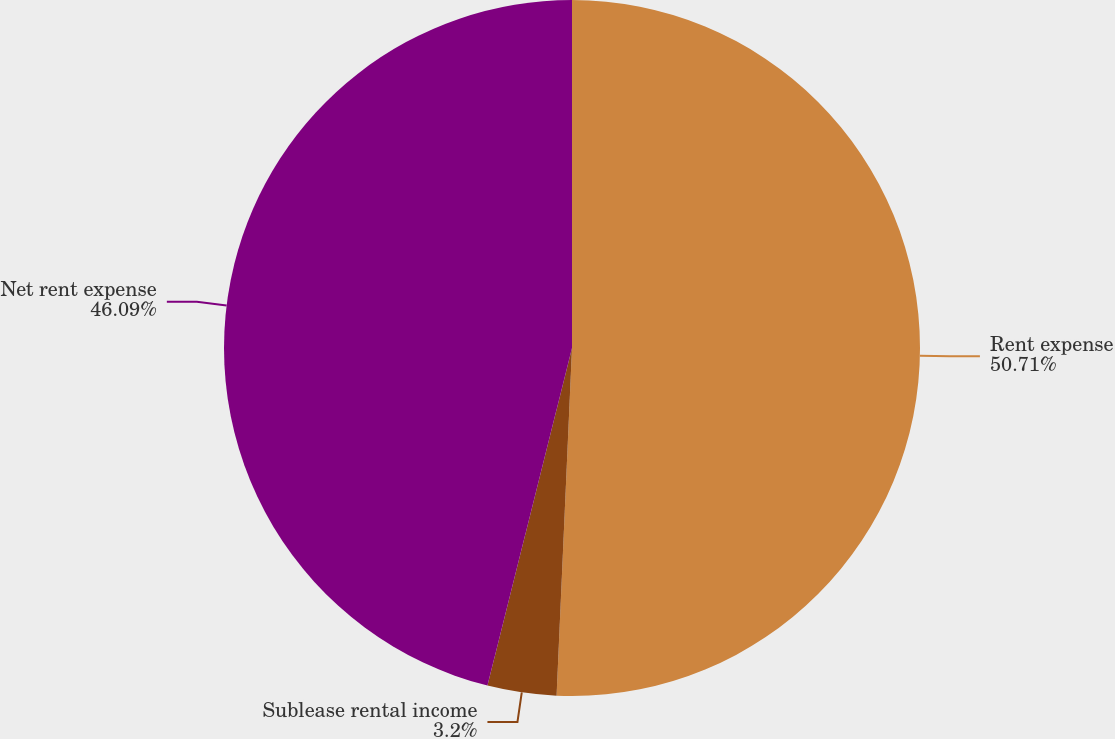Convert chart. <chart><loc_0><loc_0><loc_500><loc_500><pie_chart><fcel>Rent expense<fcel>Sublease rental income<fcel>Net rent expense<nl><fcel>50.7%<fcel>3.2%<fcel>46.09%<nl></chart> 